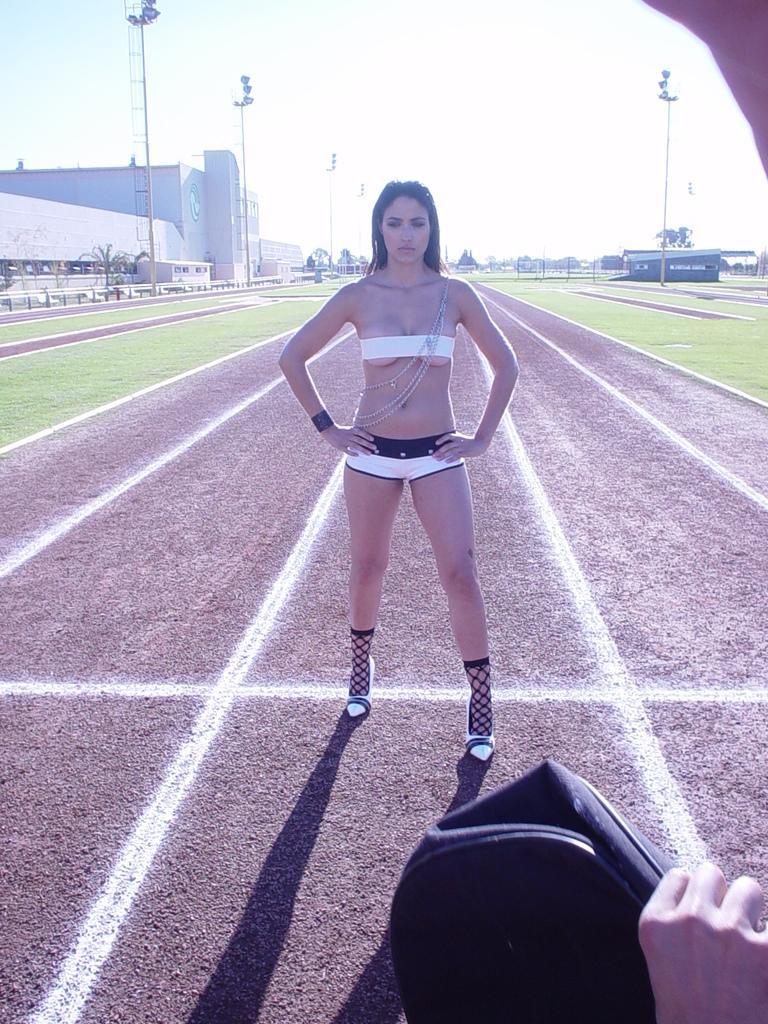Could you give a brief overview of what you see in this image? In the image there is a woman standing on the ground and in front of her there is some other person, only the hand of the person is visible, there is a lot of grass, some poles and other compartments around the woman. 